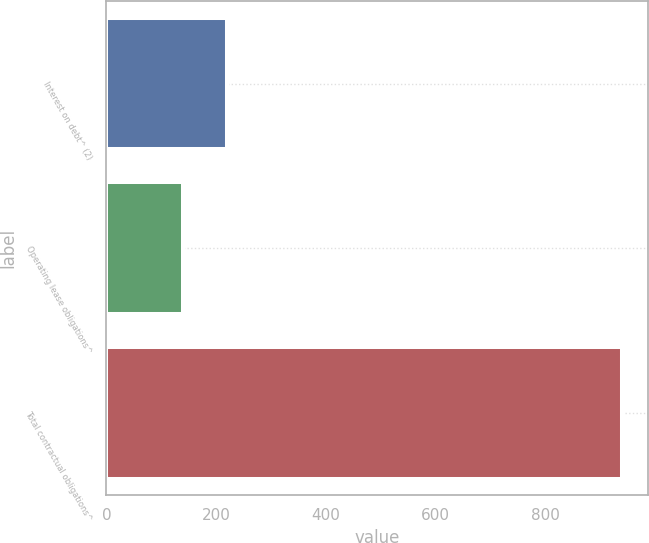Convert chart. <chart><loc_0><loc_0><loc_500><loc_500><bar_chart><fcel>Interest on debt^ (2)<fcel>Operating lease obligations^<fcel>Total contractual obligations^<nl><fcel>219.92<fcel>139.8<fcel>941<nl></chart> 